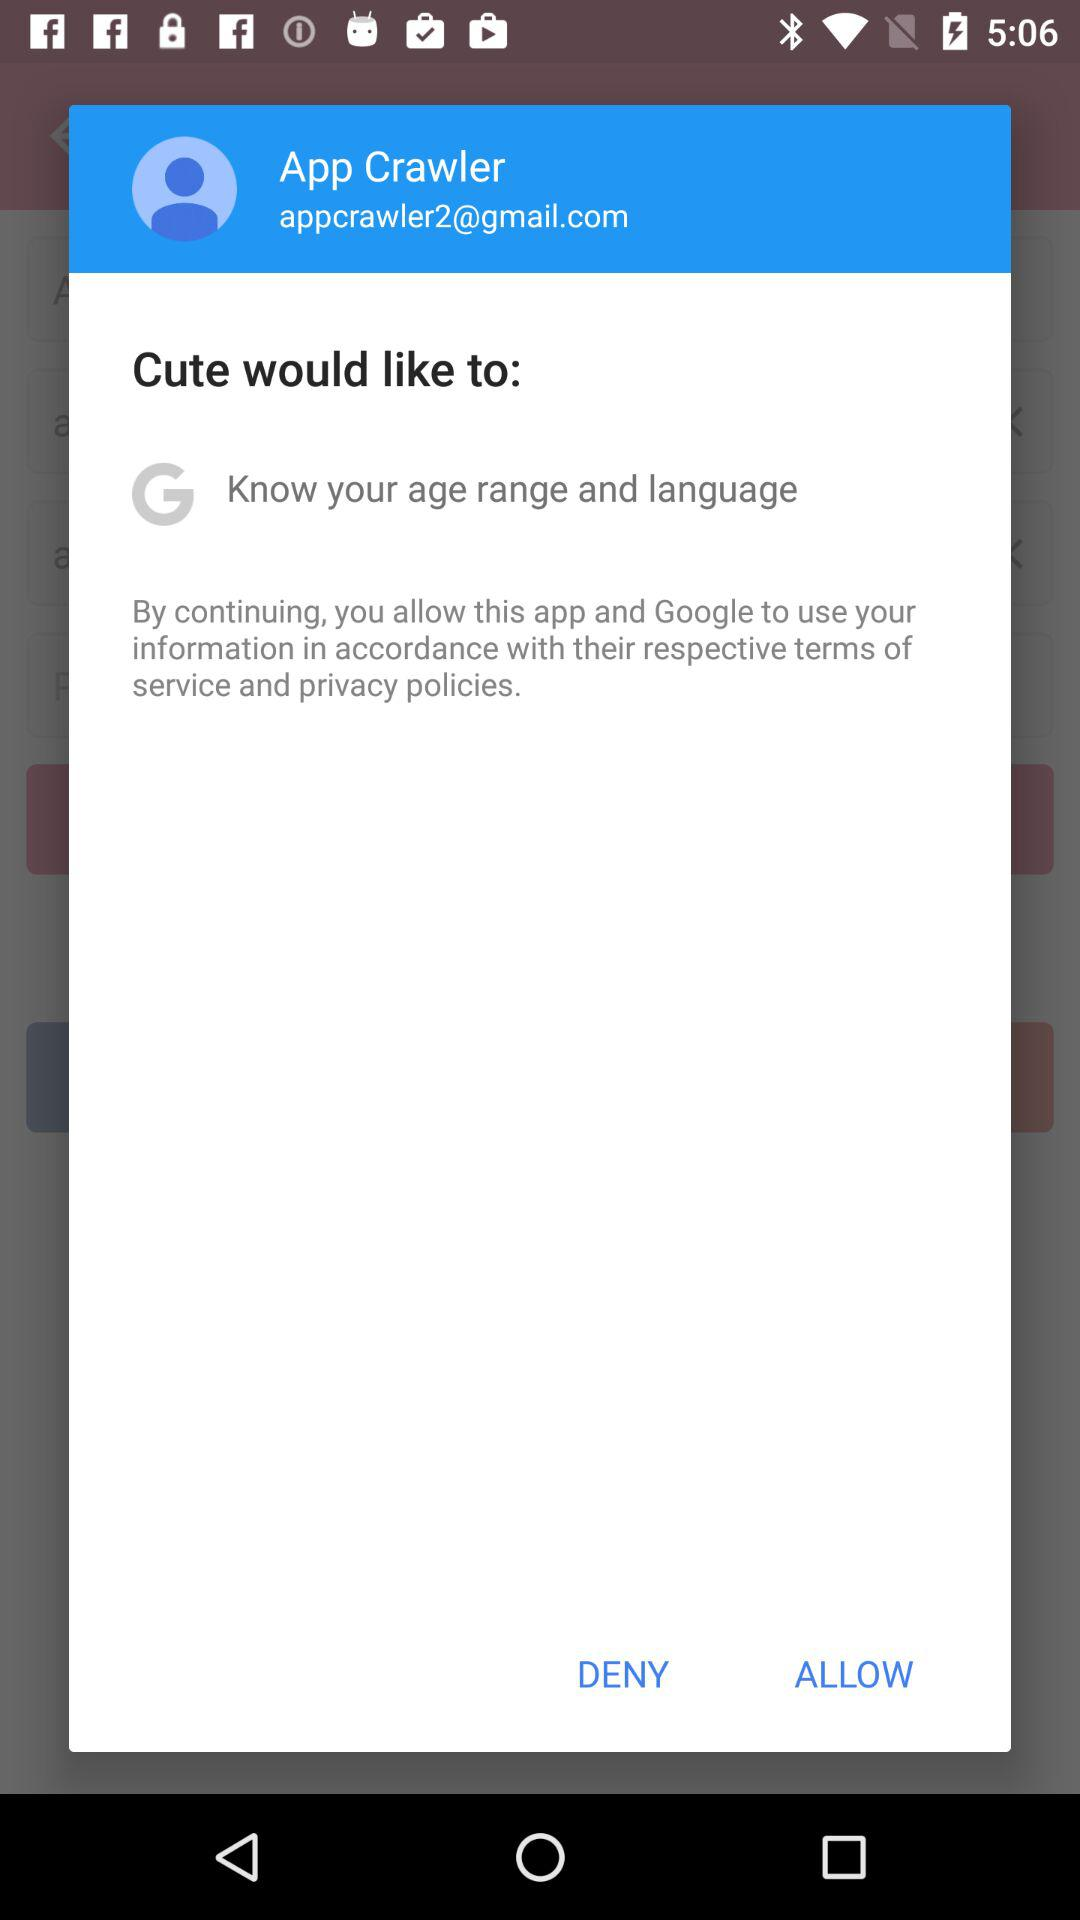What is the name of the user? The name of the user is App Crawler. 